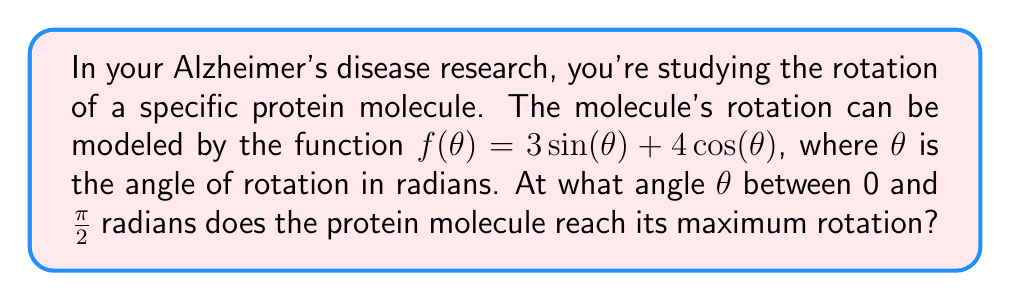Can you answer this question? To find the maximum rotation, we need to find the angle $\theta$ where the derivative of $f(\theta)$ equals zero. Let's approach this step-by-step:

1) First, let's find the derivative of $f(\theta)$:
   $$f'(\theta) = 3\cos(\theta) - 4\sin(\theta)$$

2) Set the derivative equal to zero:
   $$3\cos(\theta) - 4\sin(\theta) = 0$$

3) Divide both sides by $\cos(\theta)$ (assuming $\cos(\theta) \neq 0$):
   $$3 - 4\tan(\theta) = 0$$

4) Solve for $\tan(\theta)$:
   $$\tan(\theta) = \frac{3}{4}$$

5) To find $\theta$, we need to use the inverse tangent function:
   $$\theta = \arctan(\frac{3}{4})$$

6) This gives us the angle in radians. We can verify it's between 0 and $\frac{\pi}{2}$.

7) To get a numerical value, we can use a calculator:
   $$\theta \approx 0.6435 \text{ radians}$$

8) We can convert this to degrees if needed:
   $$\theta \approx 36.87^\circ$$

This angle represents the rotation at which the protein molecule reaches its maximum rotation according to the given model.
Answer: $\theta = \arctan(\frac{3}{4}) \approx 0.6435 \text{ radians}$ or $36.87^\circ$ 